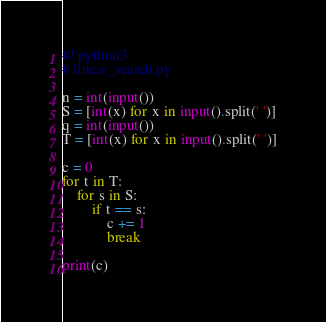<code> <loc_0><loc_0><loc_500><loc_500><_Python_>#! python3
# linear_search.py

n = int(input())
S = [int(x) for x in input().split(' ')]
q = int(input())
T = [int(x) for x in input().split(' ')]

c = 0
for t in T:
    for s in S:
        if t == s:
            c += 1
            break

print(c)

</code> 